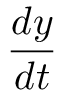<formula> <loc_0><loc_0><loc_500><loc_500>\frac { d y } { d t }</formula> 